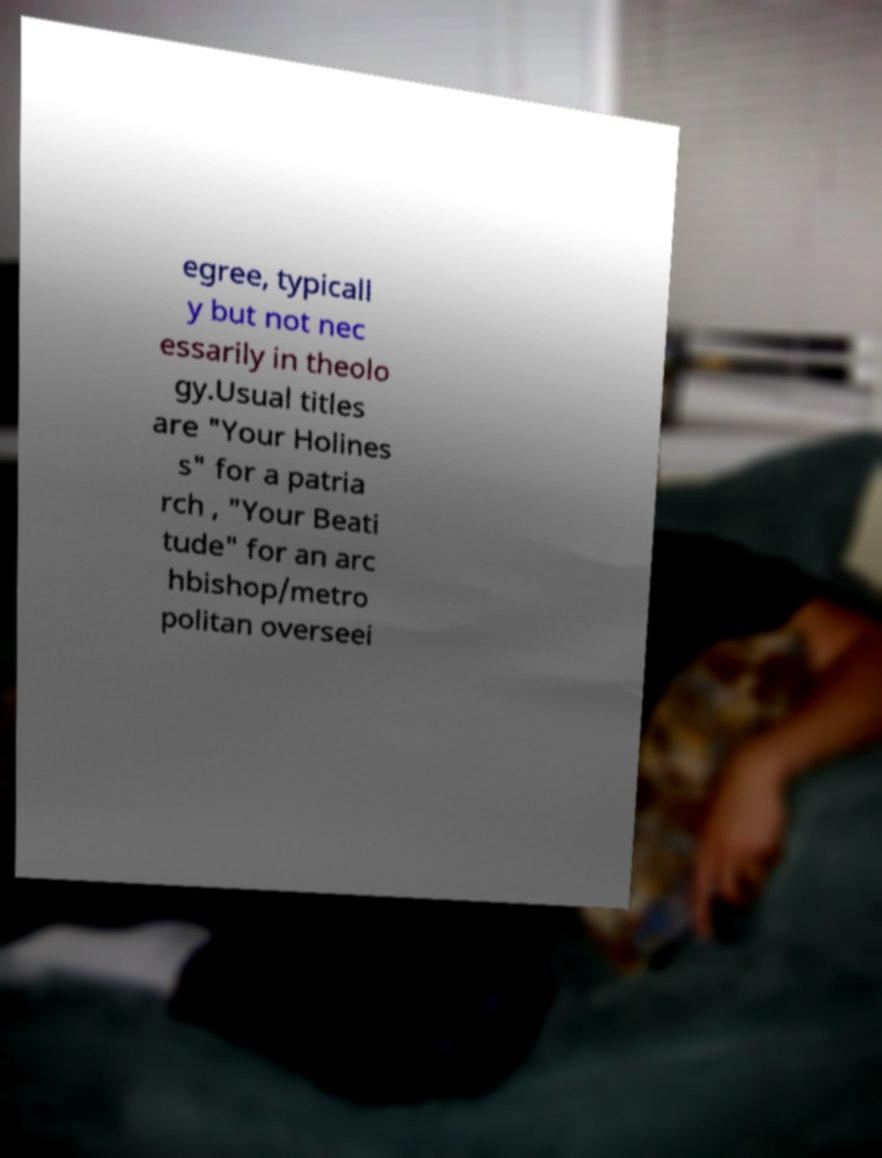Can you read and provide the text displayed in the image?This photo seems to have some interesting text. Can you extract and type it out for me? egree, typicall y but not nec essarily in theolo gy.Usual titles are "Your Holines s" for a patria rch , "Your Beati tude" for an arc hbishop/metro politan overseei 